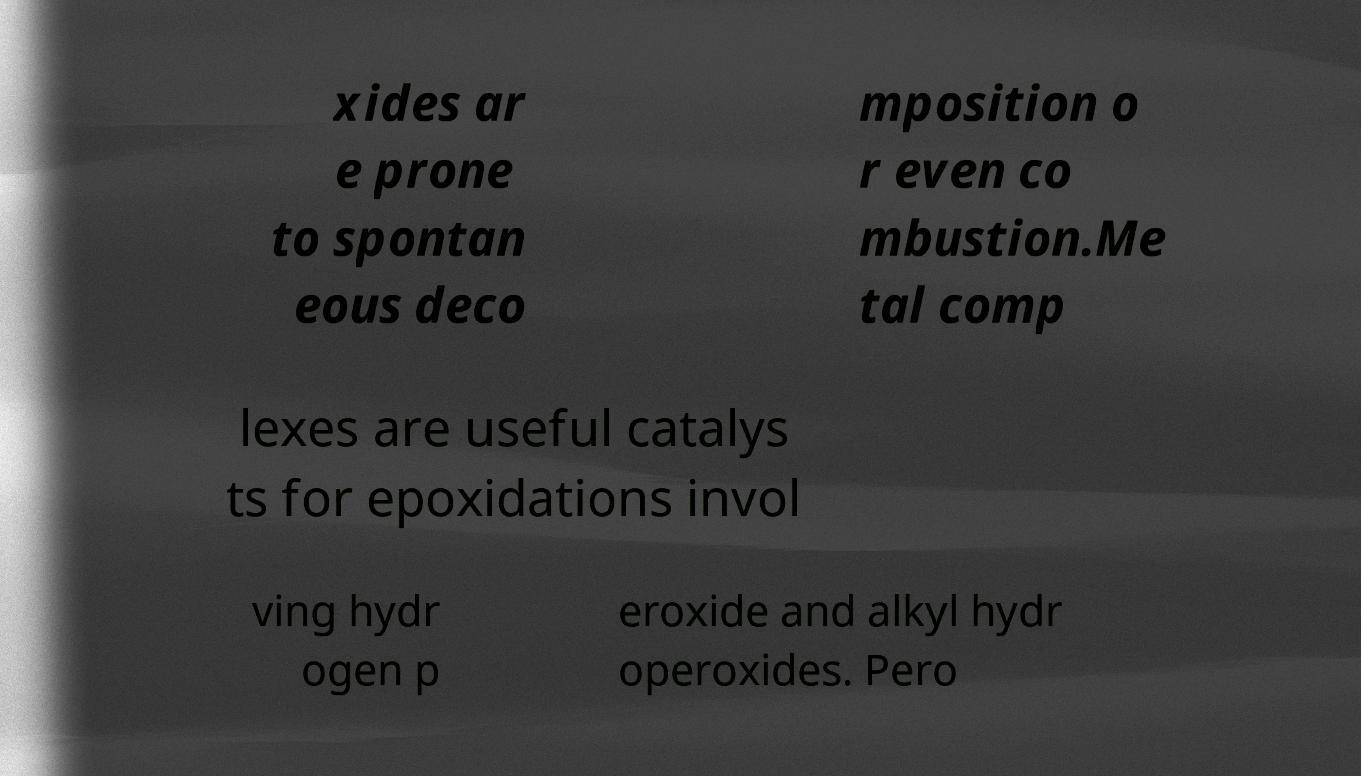Could you extract and type out the text from this image? xides ar e prone to spontan eous deco mposition o r even co mbustion.Me tal comp lexes are useful catalys ts for epoxidations invol ving hydr ogen p eroxide and alkyl hydr operoxides. Pero 